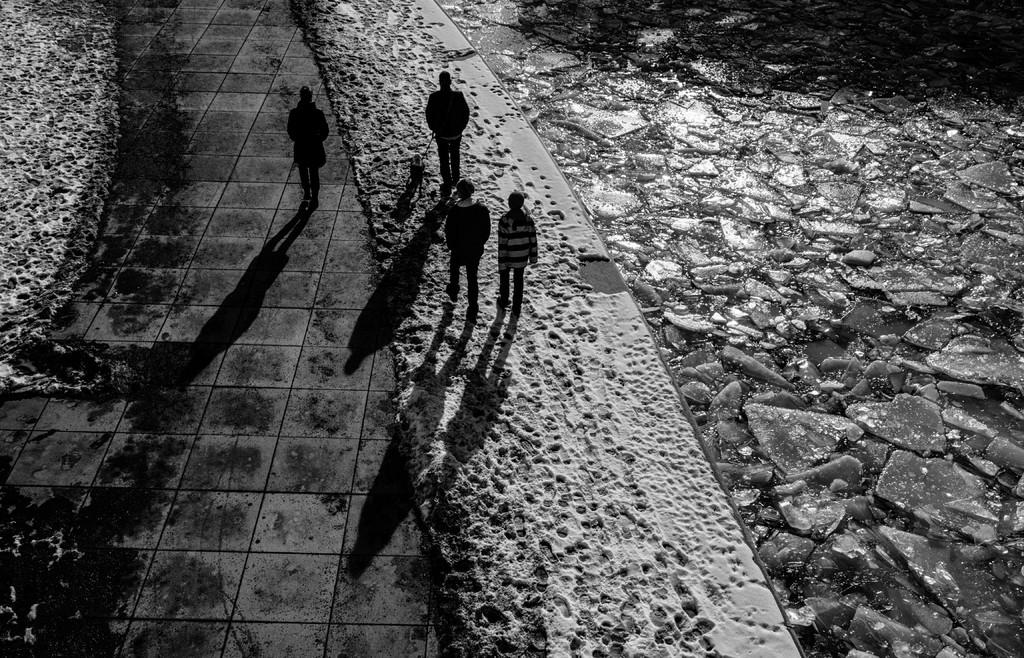What are the people in the image doing? The people in the image are walking. What surface are the people walking on? The people are walking on the land. What can be seen on the right side of the image? There is a stone path on the right side of the image. What color scheme is used in the image? The image is black and white. Where is the head of the coal located in the image? There is no coal present in the image, so it is not possible to determine the location of its head. What type of garden can be seen in the image? There is no garden present in the image. 